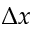Convert formula to latex. <formula><loc_0><loc_0><loc_500><loc_500>\Delta x</formula> 